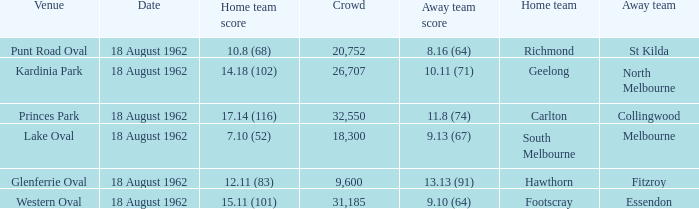At what venue where the home team scored 12.11 (83) was the crowd larger than 31,185? None. 